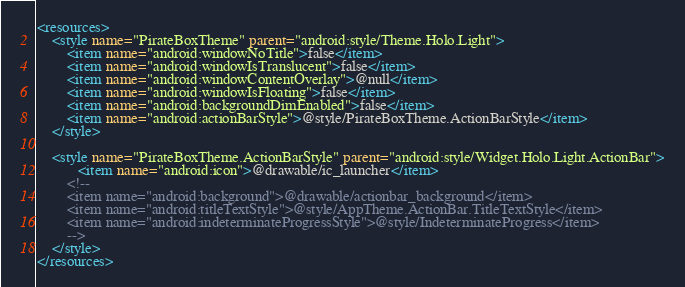<code> <loc_0><loc_0><loc_500><loc_500><_XML_><resources>
	<style name="PirateBoxTheme" parent="android:style/Theme.Holo.Light">
	    <item name="android:windowNoTitle">false</item>
		<item name="android:windowIsTranslucent">false</item>
	    <item name="android:windowContentOverlay">@null</item>
	    <item name="android:windowIsFloating">false</item>
	    <item name="android:backgroundDimEnabled">false</item>
	    <item name="android:actionBarStyle">@style/PirateBoxTheme.ActionBarStyle</item>
	</style>
	
	<style name="PirateBoxTheme.ActionBarStyle" parent="android:style/Widget.Holo.Light.ActionBar">
	       <item name="android:icon">@drawable/ic_launcher</item>
	    <!-- 
        <item name="android:background">@drawable/actionbar_background</item>
        <item name="android:titleTextStyle">@style/AppTheme.ActionBar.TitleTextStyle</item>
        <item name="android:indeterminateProgressStyle">@style/IndeterminateProgress</item>
        -->
    </style>
</resources></code> 